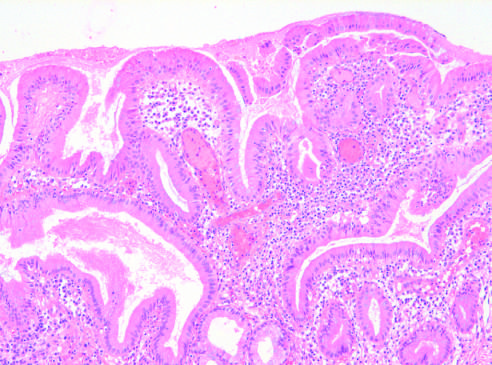s a subnodule infiltrated by chronic inflammatory cells?
Answer the question using a single word or phrase. No 